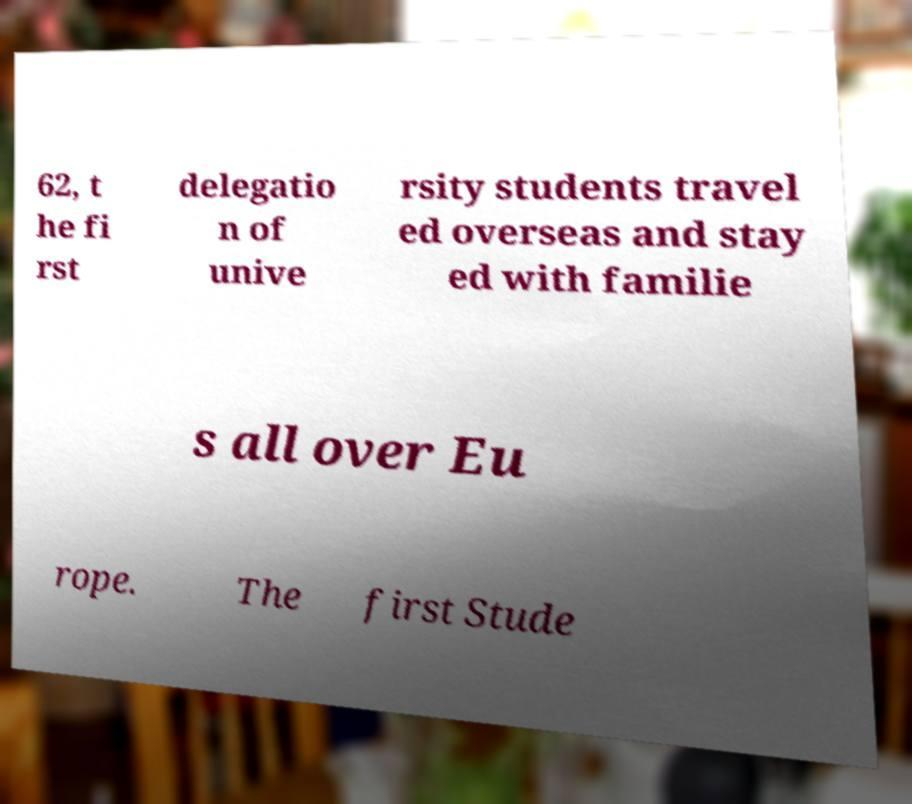What messages or text are displayed in this image? I need them in a readable, typed format. 62, t he fi rst delegatio n of unive rsity students travel ed overseas and stay ed with familie s all over Eu rope. The first Stude 